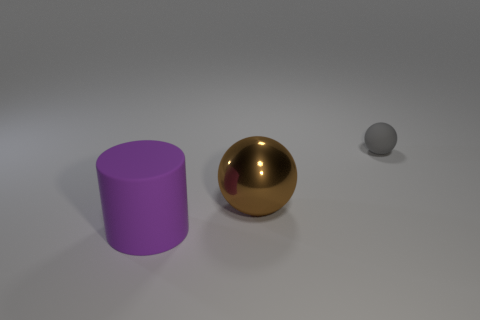What material do the objects appear to be made of based on their surfaces? Based on the reflections and textures, the violet object appears to be made of a matte material, possibly plastic. The golden sphere has a reflective surface, suggesting it could be a polished metal. The tiny grey sphere looks like it's also made of a matte material with a surface less reflective than the golden sphere. 